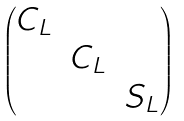Convert formula to latex. <formula><loc_0><loc_0><loc_500><loc_500>\begin{pmatrix} C _ { L } & & \\ & C _ { L } & \\ & & S _ { L } \end{pmatrix}</formula> 